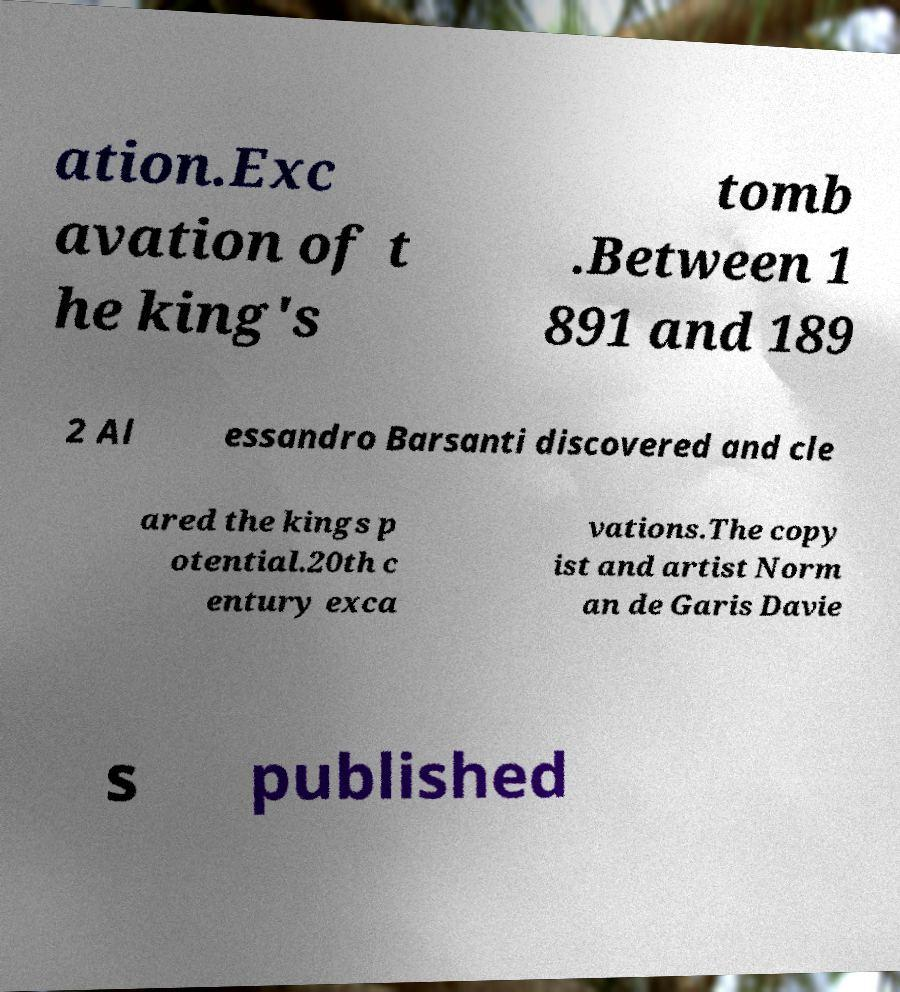Can you read and provide the text displayed in the image?This photo seems to have some interesting text. Can you extract and type it out for me? ation.Exc avation of t he king's tomb .Between 1 891 and 189 2 Al essandro Barsanti discovered and cle ared the kings p otential.20th c entury exca vations.The copy ist and artist Norm an de Garis Davie s published 